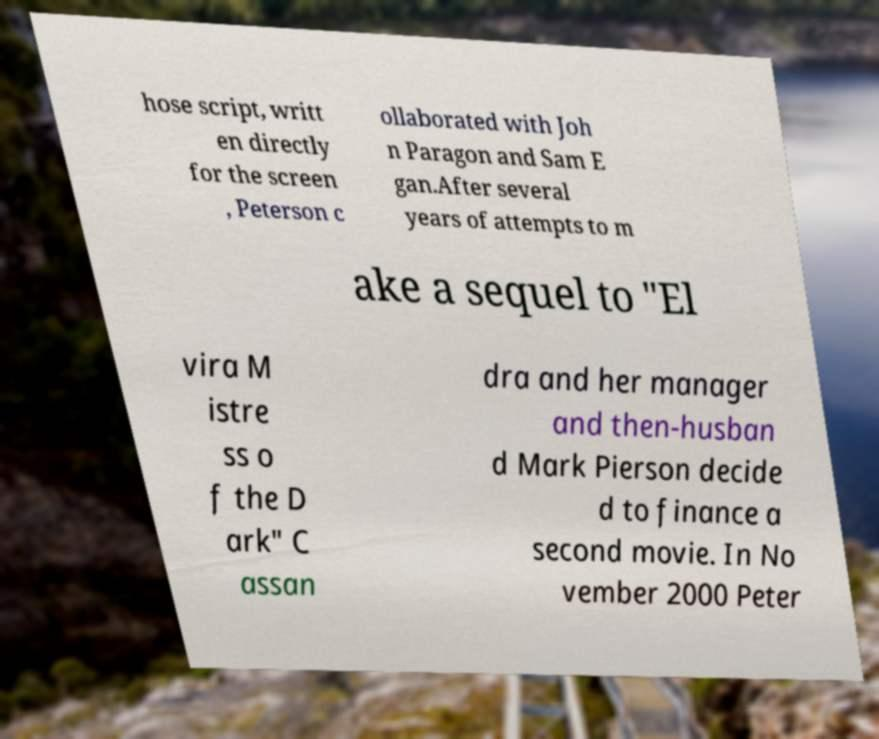Can you read and provide the text displayed in the image?This photo seems to have some interesting text. Can you extract and type it out for me? hose script, writt en directly for the screen , Peterson c ollaborated with Joh n Paragon and Sam E gan.After several years of attempts to m ake a sequel to "El vira M istre ss o f the D ark" C assan dra and her manager and then-husban d Mark Pierson decide d to finance a second movie. In No vember 2000 Peter 